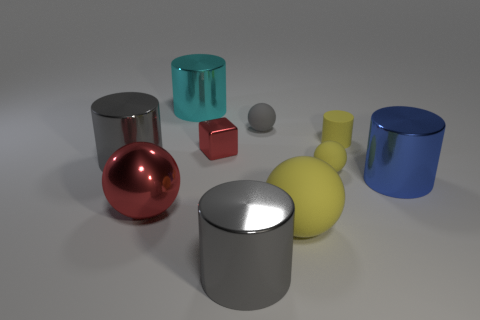How many yellow balls must be subtracted to get 1 yellow balls? 1 Subtract 3 cylinders. How many cylinders are left? 2 Subtract all large blue metal cylinders. How many cylinders are left? 4 Subtract all cyan cylinders. How many cylinders are left? 4 Subtract all blue cylinders. Subtract all green cubes. How many cylinders are left? 4 Subtract all blocks. How many objects are left? 9 Subtract 0 purple blocks. How many objects are left? 10 Subtract all tiny green objects. Subtract all tiny red shiny cubes. How many objects are left? 9 Add 6 spheres. How many spheres are left? 10 Add 5 large brown spheres. How many large brown spheres exist? 5 